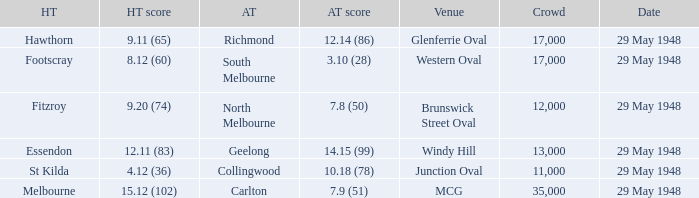During melbourne's home game, who was the away team? Carlton. 